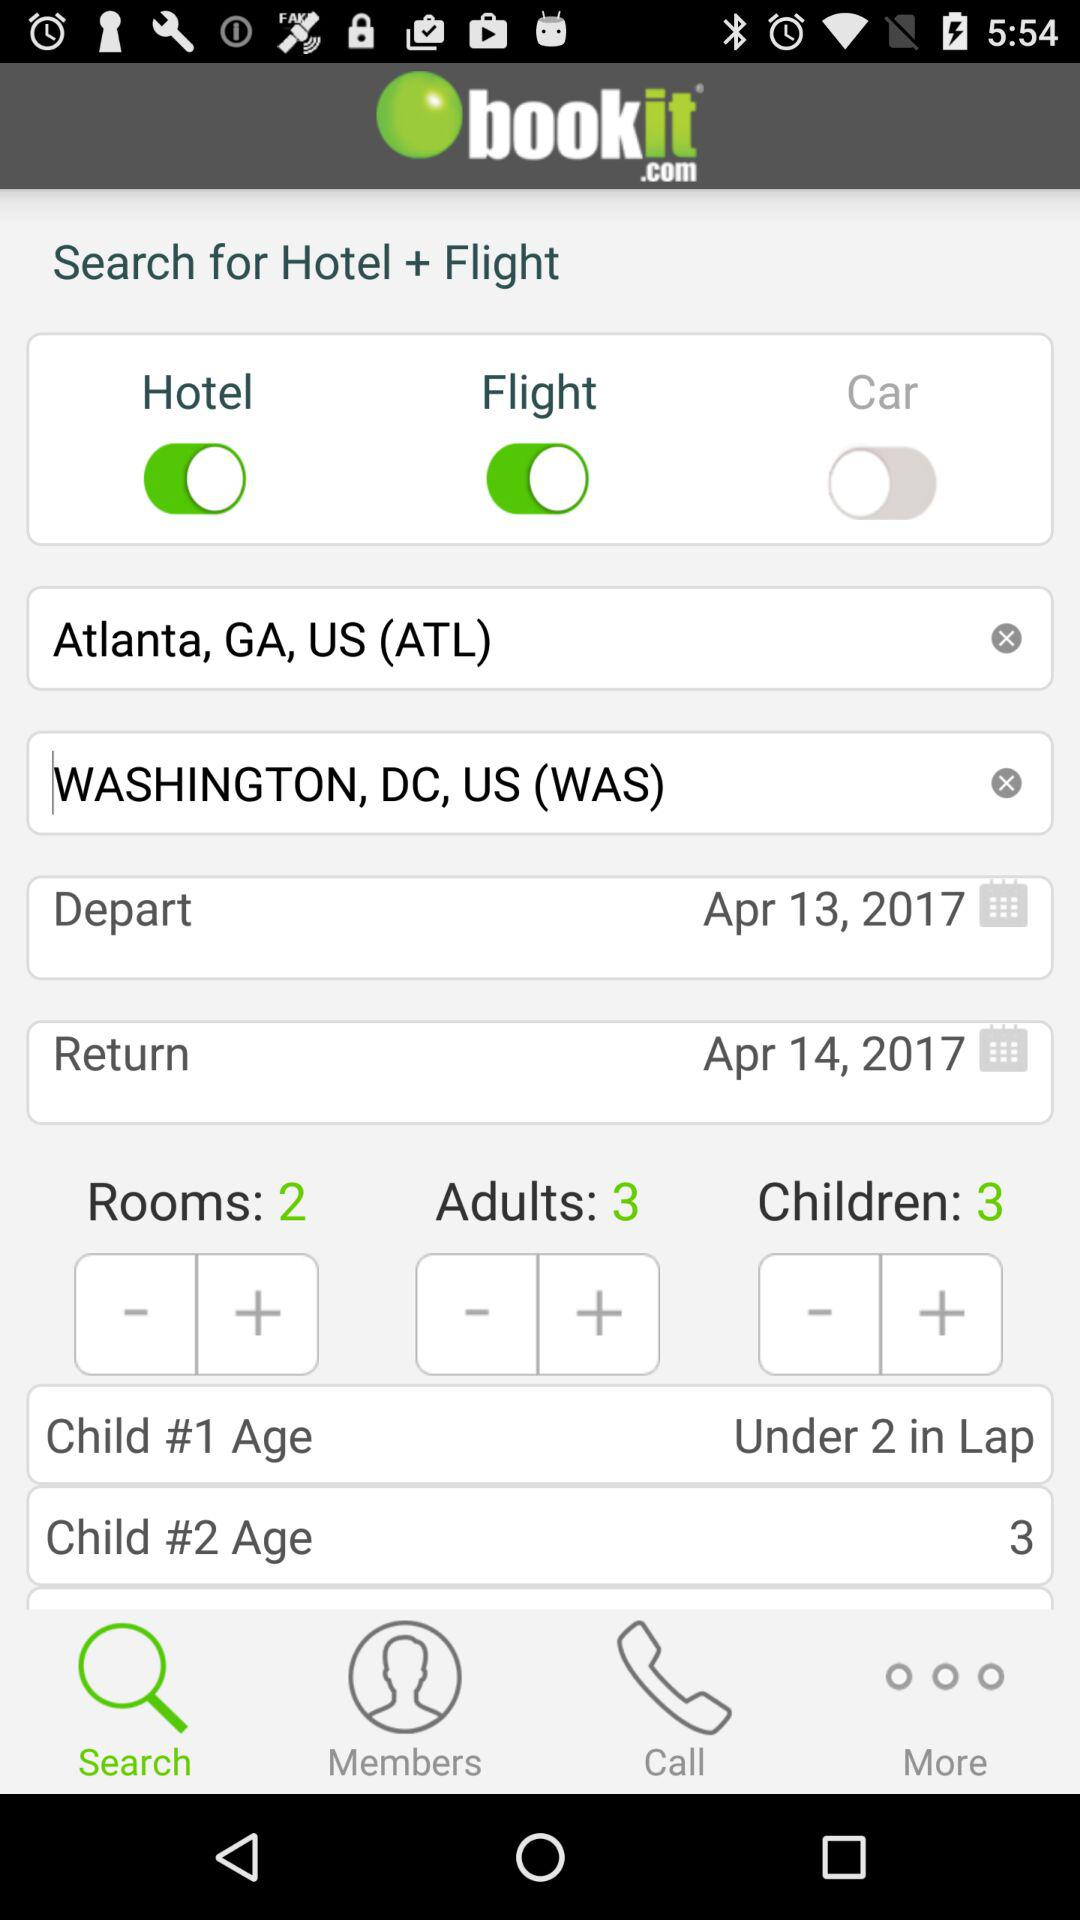How many rooms are there? There are 2 rooms. 